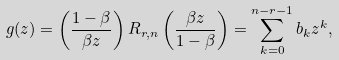Convert formula to latex. <formula><loc_0><loc_0><loc_500><loc_500>g ( z ) = \left ( \frac { 1 - \beta } { \beta z } \right ) R _ { r , n } \left ( \frac { \beta z } { 1 - \beta } \right ) = \sum _ { k = 0 } ^ { n - r - 1 } b _ { k } z ^ { k } ,</formula> 